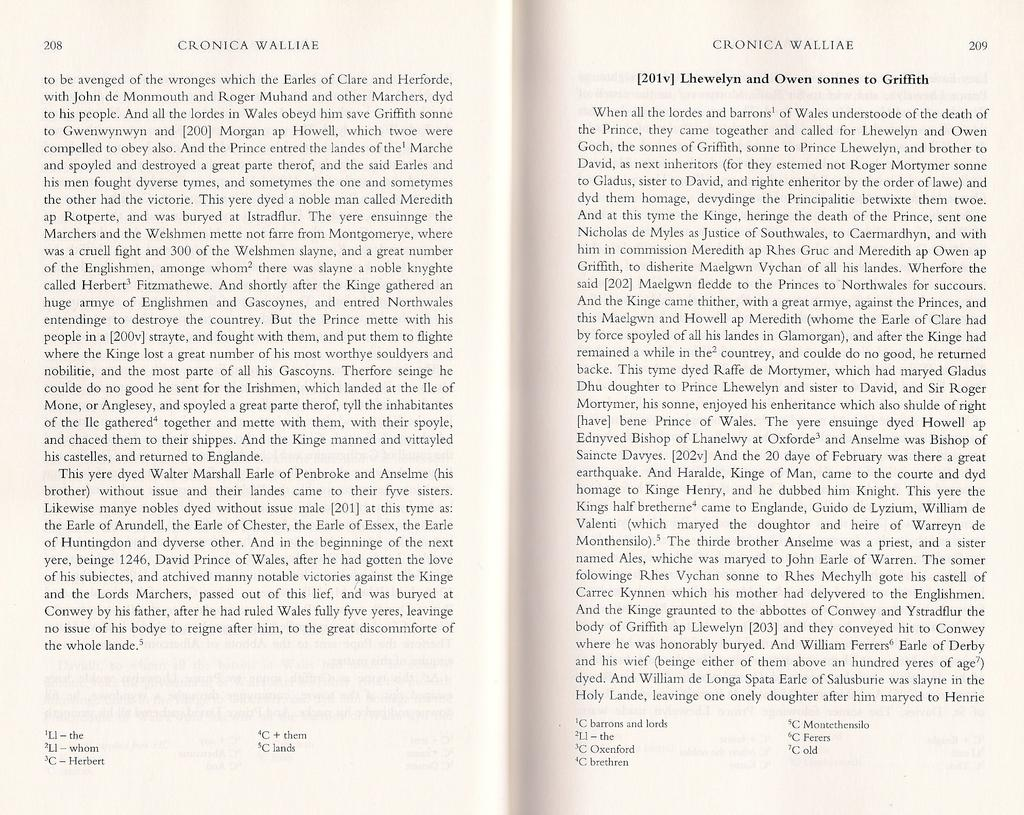How many pages are visible in the image? There are two pages visible in the image. What can be found on the pages? There is text on the pages. How can the pages be identified or referenced? There are page numbers on the pages. What type of yarn is being used to hold the pages together in the image? There is no yarn present in the image; the pages are not held together by any visible means. 